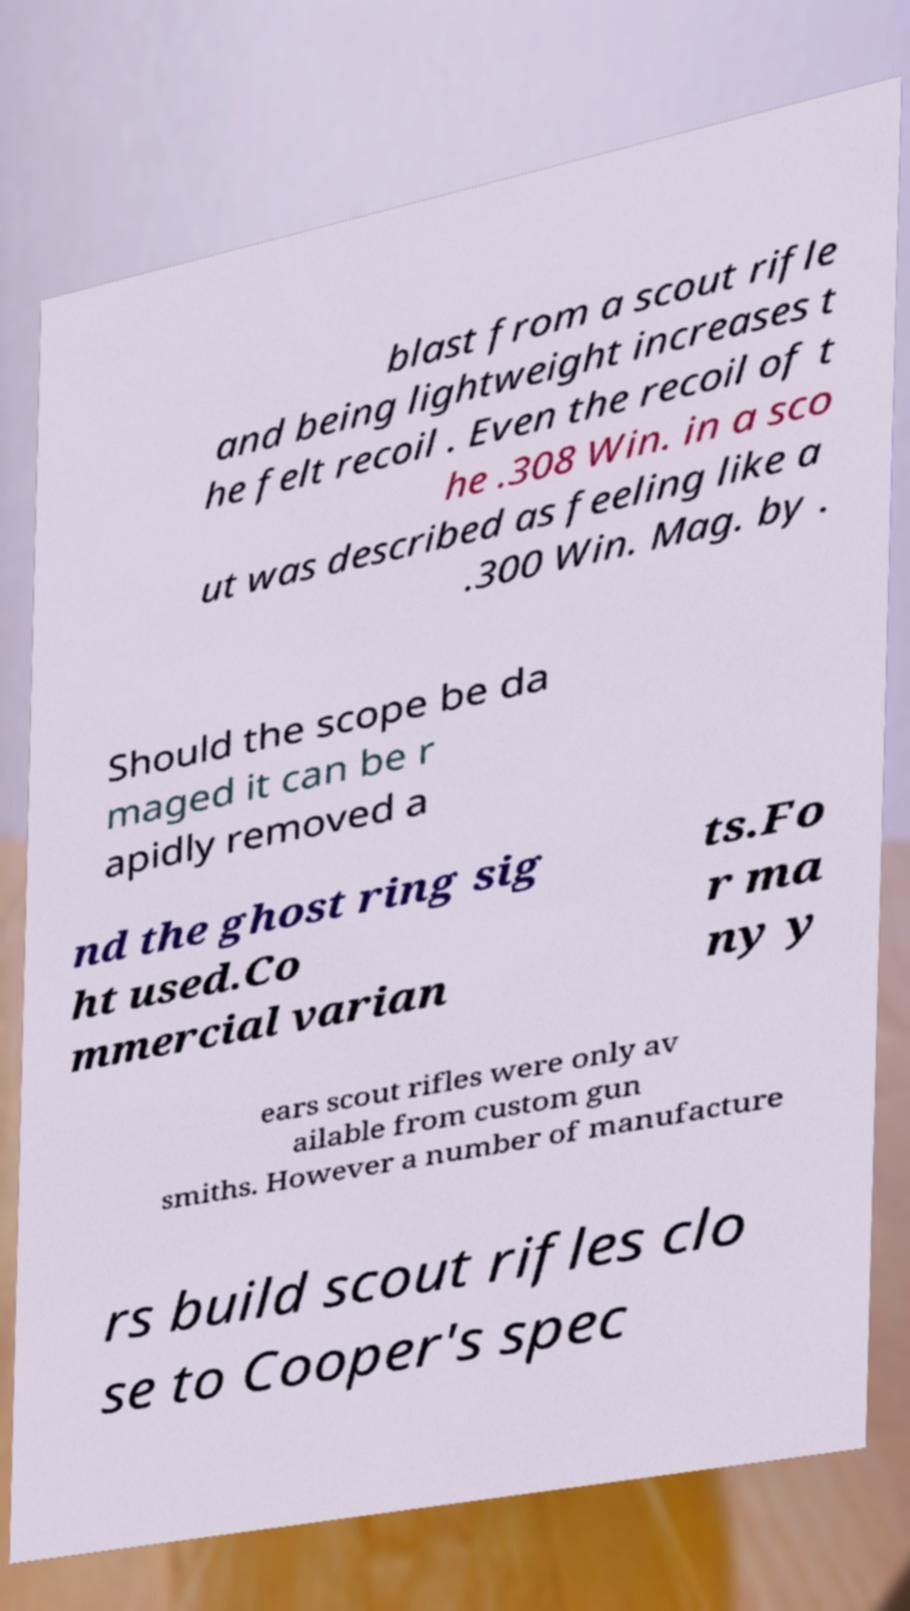For documentation purposes, I need the text within this image transcribed. Could you provide that? blast from a scout rifle and being lightweight increases t he felt recoil . Even the recoil of t he .308 Win. in a sco ut was described as feeling like a .300 Win. Mag. by . Should the scope be da maged it can be r apidly removed a nd the ghost ring sig ht used.Co mmercial varian ts.Fo r ma ny y ears scout rifles were only av ailable from custom gun smiths. However a number of manufacture rs build scout rifles clo se to Cooper's spec 